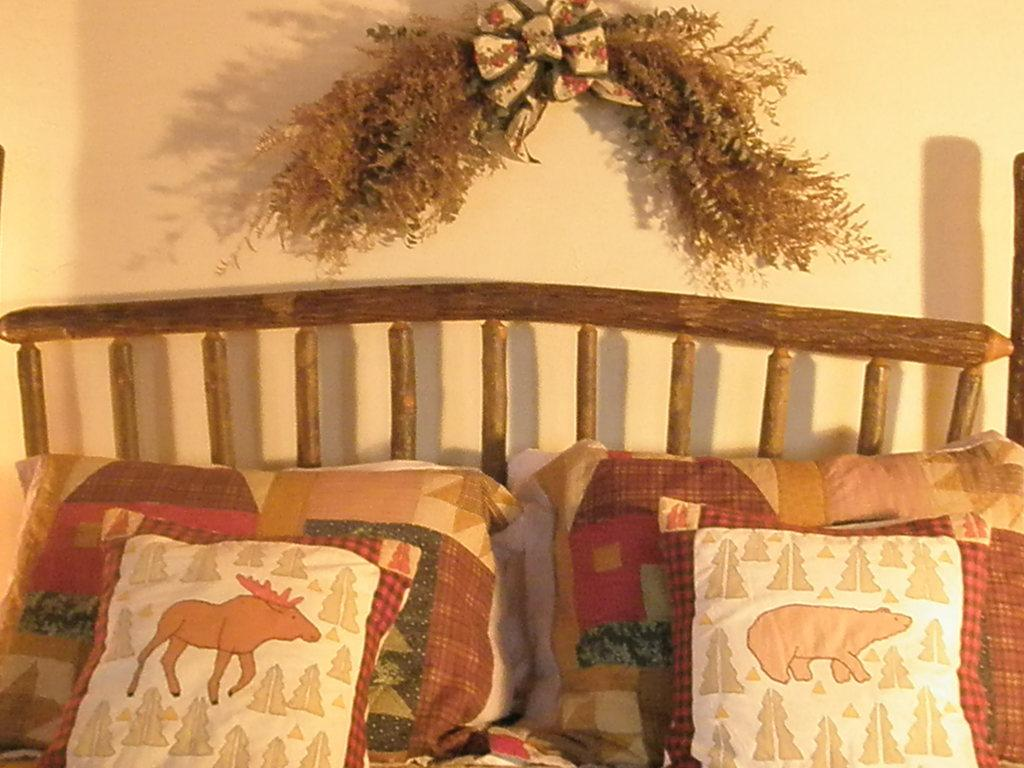How many pillows are in the image? There are 2 pillows in the image. What other items are on the cot in the image? There are 2 cushions on the cot in the image. What can be seen in the background of the image? There is a wall and decoration visible in the background of the image. How many fowl are sitting on the pillows in the image? There are no fowl present in the image; it only features pillows and cushions on a cot. What type of dust can be seen on the decoration in the image? There is no dust visible in the image, and the decoration is not described in enough detail to determine its material or potential for dust accumulation. 